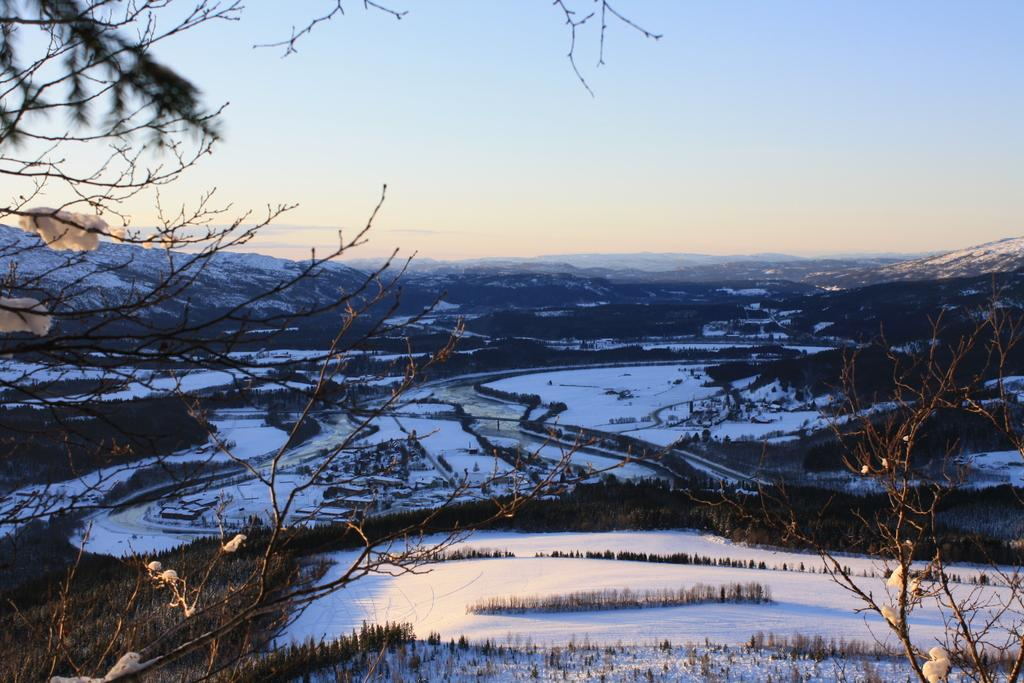What is located in the foreground of the image? There are plants in the foreground of the image. What is the surface of the foreground area like? The foreground area has a snow surface. What type of landscape can be seen in the image? The image appears to depict mountains. What is visible in the background of the image? There is snow and the sky in the background of the image. What type of protest is taking place in the image? There is no protest present in the image; it depicts a snowy landscape with mountains. Can you tell me how many insurance companies are represented in the image? There are no insurance companies present in the image. 